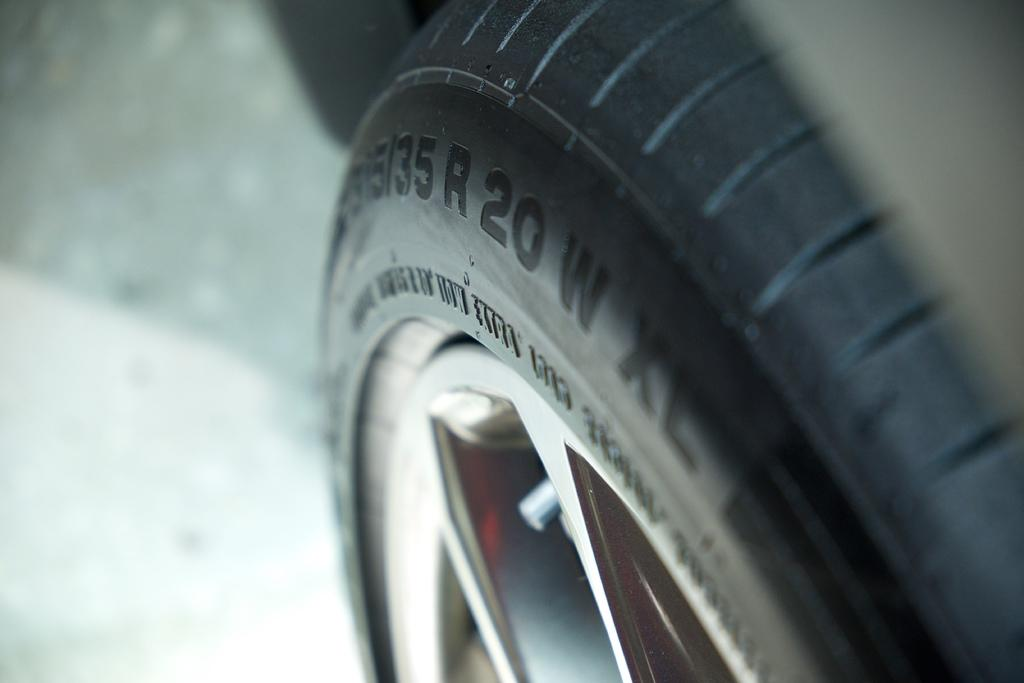What objects related to vehicles can be seen in the image? There is a tyre and a wheel in the image. Can you describe the background of the image? The background of the image is blurry. What additional detail can be observed on the tyre? There are numbers on the tyre. What type of pot can be seen in the image? There is no pot present in the image. Can you hear a horn in the image? There is no sound or audio in the image, so it is not possible to hear a horn. 